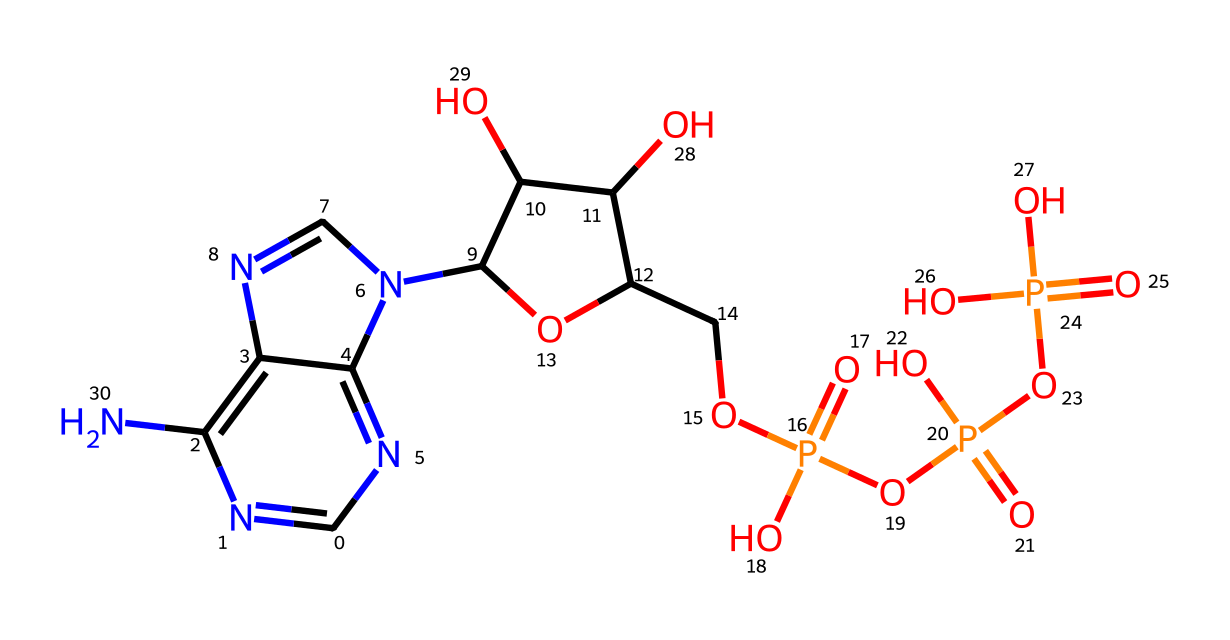What is the total number of phosphorus atoms in ATP? By examining the SMILES representation, we can identify distinct phosphorus atoms present. The molecule has three "P" notations which represent three phosphorus atoms.
Answer: three How many hydroxyl (–OH) groups are present in ATP? By analyzing the structure, we can find hydroxyl groups indicated by the presence of "O" and adjacent hydrogen in the structure. There are four –OH groups attached to the ribose sugar.
Answer: four What is the overall charge of ATP at physiological pH? The phosphate groups in ATP are negatively charged at physiological pH, and since there are four such groups, the overall charge of ATP is usually -4.
Answer: negative four What type of nucleoside is contained in ATP? The molecule contains adenine as its nitrogenous base, which is characteristic of adenine nucleosides.
Answer: adenine Which functional groups are mainly responsible for ATP's energy transfer capability? The high-energy phosphate bonds associated with the phosphate groups are responsible for energy transfer. These bonds, specifically the terminal phosphoanhydride bond, store energy.
Answer: phosphate groups What role does ribose play in ATP? Ribose serves as the sugar backbone, connecting the nitrogenous base and phosphate groups, which forms the structure of ATP.
Answer: sugar backbone Which bond type is predominant in the structure of ATP? The structure of ATP contains multiple covalent bonds between the atoms, especially between the carbon, nitrogen, oxygen, and phosphorus atoms.
Answer: covalent bonds 